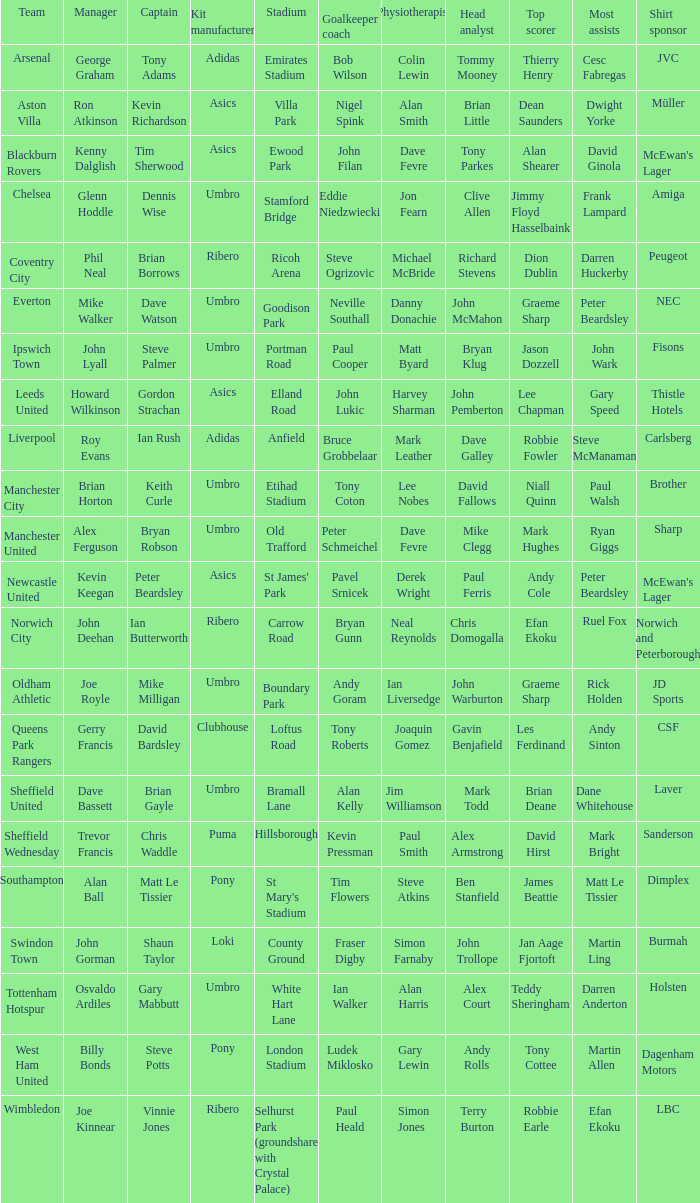Which captain has howard wilkinson as the manager? Gordon Strachan. Write the full table. {'header': ['Team', 'Manager', 'Captain', 'Kit manufacturer', 'Stadium', 'Goalkeeper coach', 'Physiotherapist', 'Head analyst', 'Top scorer', 'Most assists', 'Shirt sponsor'], 'rows': [['Arsenal', 'George Graham', 'Tony Adams', 'Adidas', 'Emirates Stadium', 'Bob Wilson', 'Colin Lewin', 'Tommy Mooney', 'Thierry Henry', 'Cesc Fabregas', 'JVC'], ['Aston Villa', 'Ron Atkinson', 'Kevin Richardson', 'Asics', 'Villa Park', 'Nigel Spink', 'Alan Smith', 'Brian Little', 'Dean Saunders', 'Dwight Yorke', 'Müller'], ['Blackburn Rovers', 'Kenny Dalglish', 'Tim Sherwood', 'Asics', 'Ewood Park', 'John Filan', 'Dave Fevre', 'Tony Parkes', 'Alan Shearer', 'David Ginola', "McEwan's Lager"], ['Chelsea', 'Glenn Hoddle', 'Dennis Wise', 'Umbro', 'Stamford Bridge', 'Eddie Niedzwiecki', 'Jon Fearn', 'Clive Allen', 'Jimmy Floyd Hasselbaink', 'Frank Lampard', 'Amiga'], ['Coventry City', 'Phil Neal', 'Brian Borrows', 'Ribero', 'Ricoh Arena', 'Steve Ogrizovic', 'Michael McBride', 'Richard Stevens', 'Dion Dublin', 'Darren Huckerby', 'Peugeot'], ['Everton', 'Mike Walker', 'Dave Watson', 'Umbro', 'Goodison Park', 'Neville Southall', 'Danny Donachie', 'John McMahon', 'Graeme Sharp', 'Peter Beardsley', 'NEC'], ['Ipswich Town', 'John Lyall', 'Steve Palmer', 'Umbro', 'Portman Road', 'Paul Cooper', 'Matt Byard', 'Bryan Klug', 'Jason Dozzell', 'John Wark', 'Fisons'], ['Leeds United', 'Howard Wilkinson', 'Gordon Strachan', 'Asics', 'Elland Road', 'John Lukic', 'Harvey Sharman', 'John Pemberton', 'Lee Chapman', 'Gary Speed', 'Thistle Hotels'], ['Liverpool', 'Roy Evans', 'Ian Rush', 'Adidas', 'Anfield', 'Bruce Grobbelaar', 'Mark Leather', 'Dave Galley', 'Robbie Fowler', 'Steve McManaman', 'Carlsberg'], ['Manchester City', 'Brian Horton', 'Keith Curle', 'Umbro', 'Etihad Stadium', 'Tony Coton', 'Lee Nobes', 'David Fallows', 'Niall Quinn', 'Paul Walsh', 'Brother'], ['Manchester United', 'Alex Ferguson', 'Bryan Robson', 'Umbro', 'Old Trafford', 'Peter Schmeichel', 'Dave Fevre', 'Mike Clegg', 'Mark Hughes', 'Ryan Giggs', 'Sharp'], ['Newcastle United', 'Kevin Keegan', 'Peter Beardsley', 'Asics', "St James' Park", 'Pavel Srnicek', 'Derek Wright', 'Paul Ferris', 'Andy Cole', 'Peter Beardsley', "McEwan's Lager"], ['Norwich City', 'John Deehan', 'Ian Butterworth', 'Ribero', 'Carrow Road', 'Bryan Gunn', 'Neal Reynolds', 'Chris Domogalla', 'Efan Ekoku', 'Ruel Fox', 'Norwich and Peterborough'], ['Oldham Athletic', 'Joe Royle', 'Mike Milligan', 'Umbro', 'Boundary Park', 'Andy Goram', 'Ian Liversedge', 'John Warburton', 'Graeme Sharp', 'Rick Holden', 'JD Sports'], ['Queens Park Rangers', 'Gerry Francis', 'David Bardsley', 'Clubhouse', 'Loftus Road', 'Tony Roberts', 'Joaquin Gomez', 'Gavin Benjafield', 'Les Ferdinand', 'Andy Sinton', 'CSF'], ['Sheffield United', 'Dave Bassett', 'Brian Gayle', 'Umbro', 'Bramall Lane', 'Alan Kelly', 'Jim Williamson', 'Mark Todd', 'Brian Deane', 'Dane Whitehouse', 'Laver'], ['Sheffield Wednesday', 'Trevor Francis', 'Chris Waddle', 'Puma', 'Hillsborough', 'Kevin Pressman', 'Paul Smith', 'Alex Armstrong', 'David Hirst', 'Mark Bright', 'Sanderson'], ['Southampton', 'Alan Ball', 'Matt Le Tissier', 'Pony', "St Mary's Stadium", 'Tim Flowers', 'Steve Atkins', 'Ben Stanfield', 'James Beattie', 'Matt Le Tissier', 'Dimplex'], ['Swindon Town', 'John Gorman', 'Shaun Taylor', 'Loki', 'County Ground', 'Fraser Digby', 'Simon Farnaby', 'John Trollope', 'Jan Aage Fjortoft', 'Martin Ling', 'Burmah'], ['Tottenham Hotspur', 'Osvaldo Ardiles', 'Gary Mabbutt', 'Umbro', 'White Hart Lane', 'Ian Walker', 'Alan Harris', 'Alex Court', 'Teddy Sheringham', 'Darren Anderton', 'Holsten'], ['West Ham United', 'Billy Bonds', 'Steve Potts', 'Pony', 'London Stadium', 'Ludek Miklosko', 'Gary Lewin', 'Andy Rolls', 'Tony Cottee', 'Martin Allen', 'Dagenham Motors'], ['Wimbledon', 'Joe Kinnear', 'Vinnie Jones', 'Ribero', 'Selhurst Park (groundshare with Crystal Palace)', 'Paul Heald', 'Simon Jones', 'Terry Burton', 'Robbie Earle', 'Efan Ekoku', 'LBC']]} 